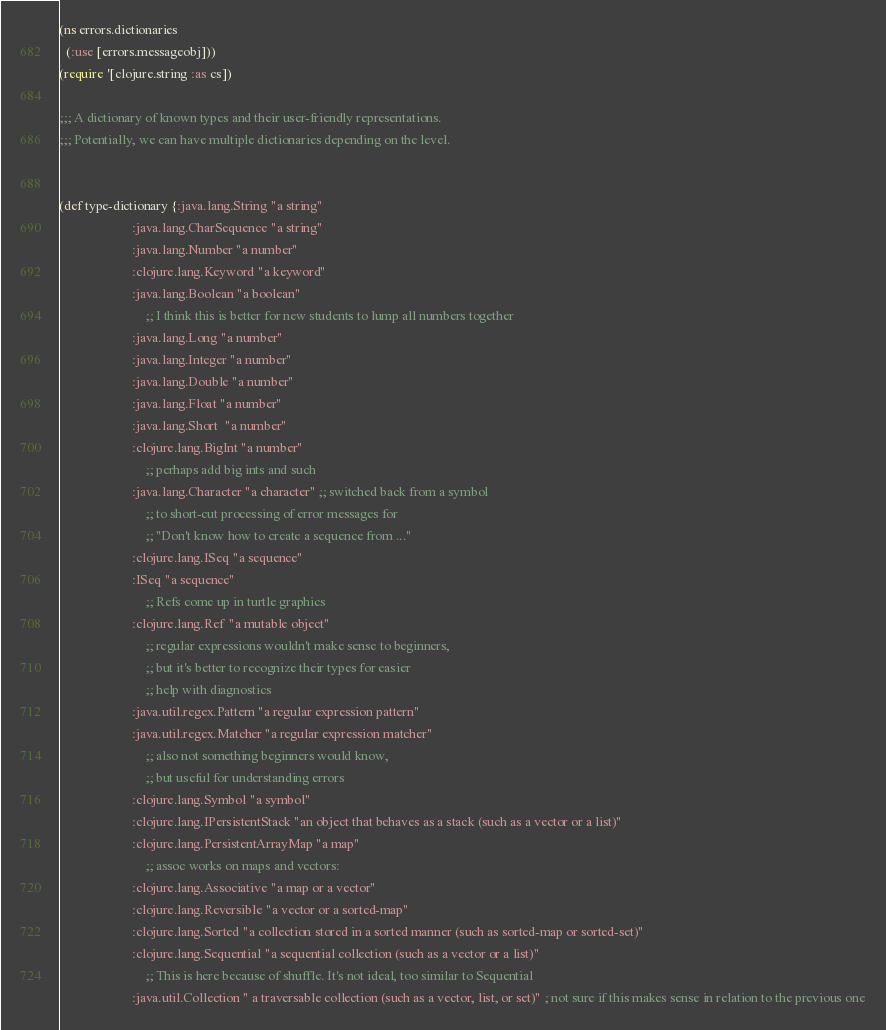<code> <loc_0><loc_0><loc_500><loc_500><_Clojure_>(ns errors.dictionaries
  (:use [errors.messageobj]))
(require '[clojure.string :as cs])

;;; A dictionary of known types and their user-friendly representations.
;;; Potentially, we can have multiple dictionaries depending on the level.


(def type-dictionary {:java.lang.String "a string"
                      :java.lang.CharSequence "a string"
                      :java.lang.Number "a number"
                      :clojure.lang.Keyword "a keyword"
                      :java.lang.Boolean "a boolean"
		                  ;; I think this is better for new students to lump all numbers together
                      :java.lang.Long "a number"
                      :java.lang.Integer "a number"
                      :java.lang.Double "a number"
                      :java.lang.Float "a number"
                      :java.lang.Short  "a number"
                      :clojure.lang.BigInt "a number"
		                  ;; perhaps add big ints and such
                      :java.lang.Character "a character" ;; switched back from a symbol
		                  ;; to short-cut processing of error messages for
		                  ;; "Don't know how to create a sequence from ..."
                      :clojure.lang.ISeq "a sequence"
                      :ISeq "a sequence"
		                  ;; Refs come up in turtle graphics
                      :clojure.lang.Ref "a mutable object"
		                  ;; regular expressions wouldn't make sense to beginners,
		                  ;; but it's better to recognize their types for easier
		                  ;; help with diagnostics
                      :java.util.regex.Pattern "a regular expression pattern"
                      :java.util.regex.Matcher "a regular expression matcher"
		                  ;; also not something beginners would know,
		                  ;; but useful for understanding errors
                      :clojure.lang.Symbol "a symbol"
                      :clojure.lang.IPersistentStack "an object that behaves as a stack (such as a vector or a list)"
                      :clojure.lang.PersistentArrayMap "a map"
		                  ;; assoc works on maps and vectors:
                      :clojure.lang.Associative "a map or a vector"
                      :clojure.lang.Reversible "a vector or a sorted-map"
                      :clojure.lang.Sorted "a collection stored in a sorted manner (such as sorted-map or sorted-set)"
                      :clojure.lang.Sequential "a sequential collection (such as a vector or a list)"
		                  ;; This is here because of shuffle. It's not ideal, too similar to Sequential
                      :java.util.Collection " a traversable collection (such as a vector, list, or set)" ; not sure if this makes sense in relation to the previous one</code> 